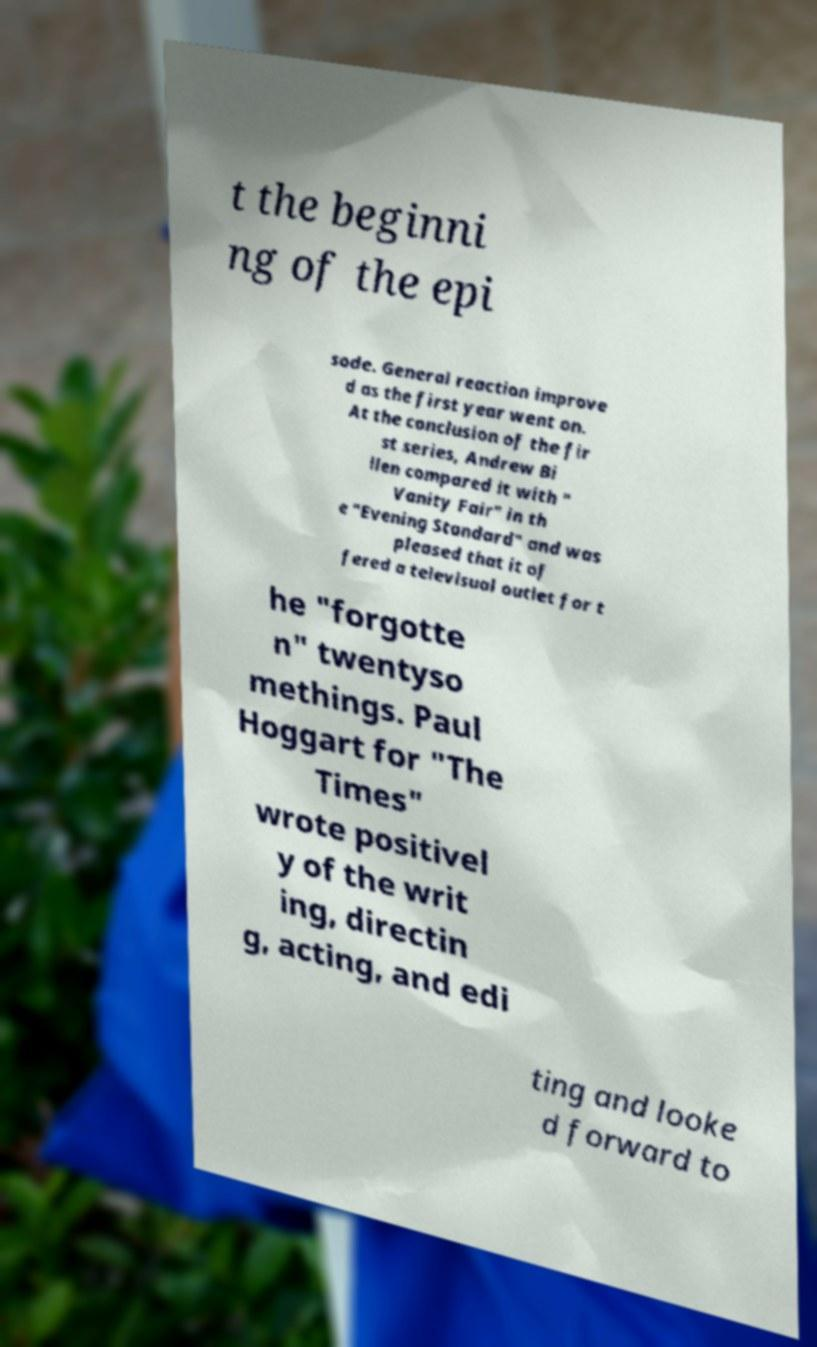I need the written content from this picture converted into text. Can you do that? t the beginni ng of the epi sode. General reaction improve d as the first year went on. At the conclusion of the fir st series, Andrew Bi llen compared it with " Vanity Fair" in th e "Evening Standard" and was pleased that it of fered a televisual outlet for t he "forgotte n" twentyso methings. Paul Hoggart for "The Times" wrote positivel y of the writ ing, directin g, acting, and edi ting and looke d forward to 